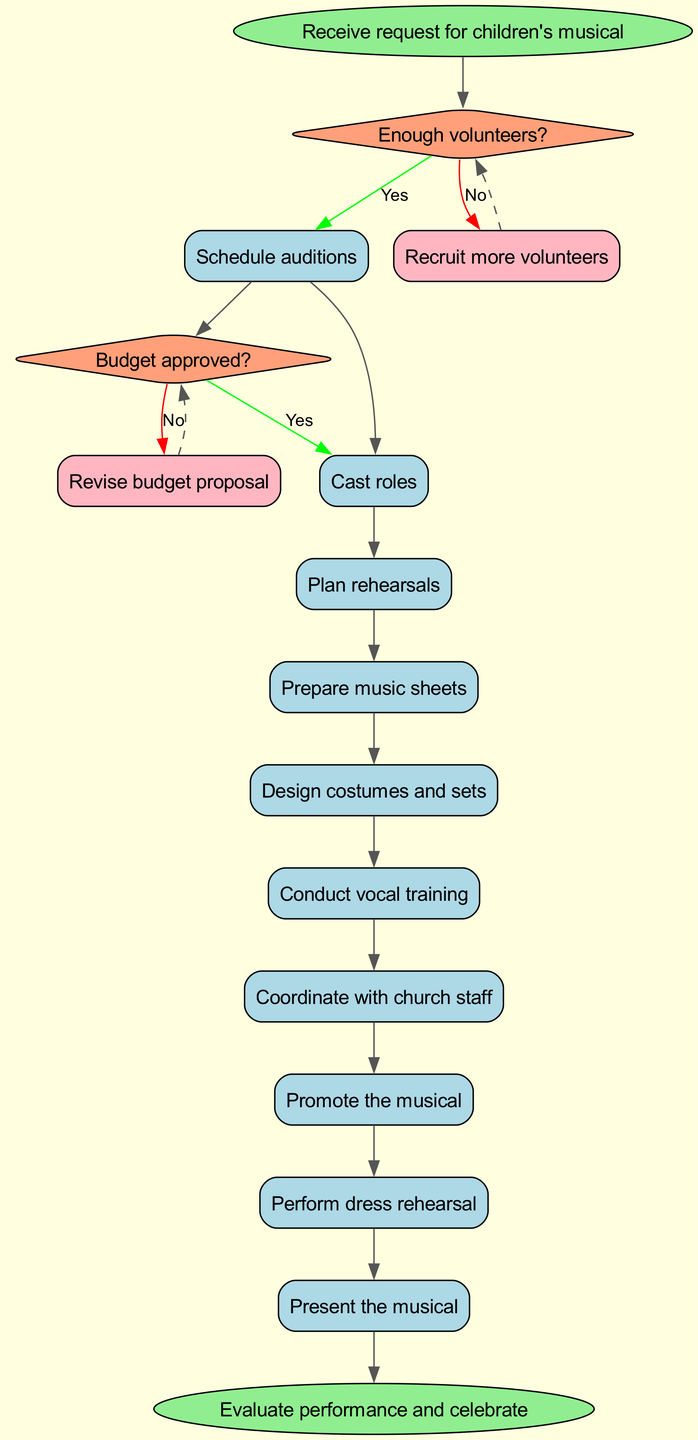What is the starting point of the process? The starting point of the process is indicated by the "start" node in the diagram, which states "Receive request for children's musical."
Answer: Receive request for children's musical How many decision points are in the flow chart? The flow chart contains two decision points, which are related to "Enough volunteers?" and "Budget approved?".
Answer: 2 What is the first process after the decision on volunteers? After deciding about the volunteers, the first process listed is "Form production team."
Answer: Form production team Which process follows "Select musical script"? The diagram shows that the process that follows "Select musical script" is "Schedule auditions."
Answer: Schedule auditions What happens if there are not enough volunteers? If there are not enough volunteers, the next action is to "Recruit more volunteers."
Answer: Recruit more volunteers What do you evaluate after presenting the musical? After presenting the musical, the final step is to "Evaluate performance and celebrate."
Answer: Evaluate performance and celebrate What is the color of the decision nodes in the diagram? The decision nodes in the diagram are colored "lightsalmon."
Answer: lightsalmon How is the process of creating costumes and sets represented in the flow chart? The process of creating costumes and sets is represented as "Design costumes and sets" in the sequence of processes.
Answer: Design costumes and sets What is the last process indicated before the final evaluation? The last process indicated before the final evaluation is "Present the musical."
Answer: Present the musical 